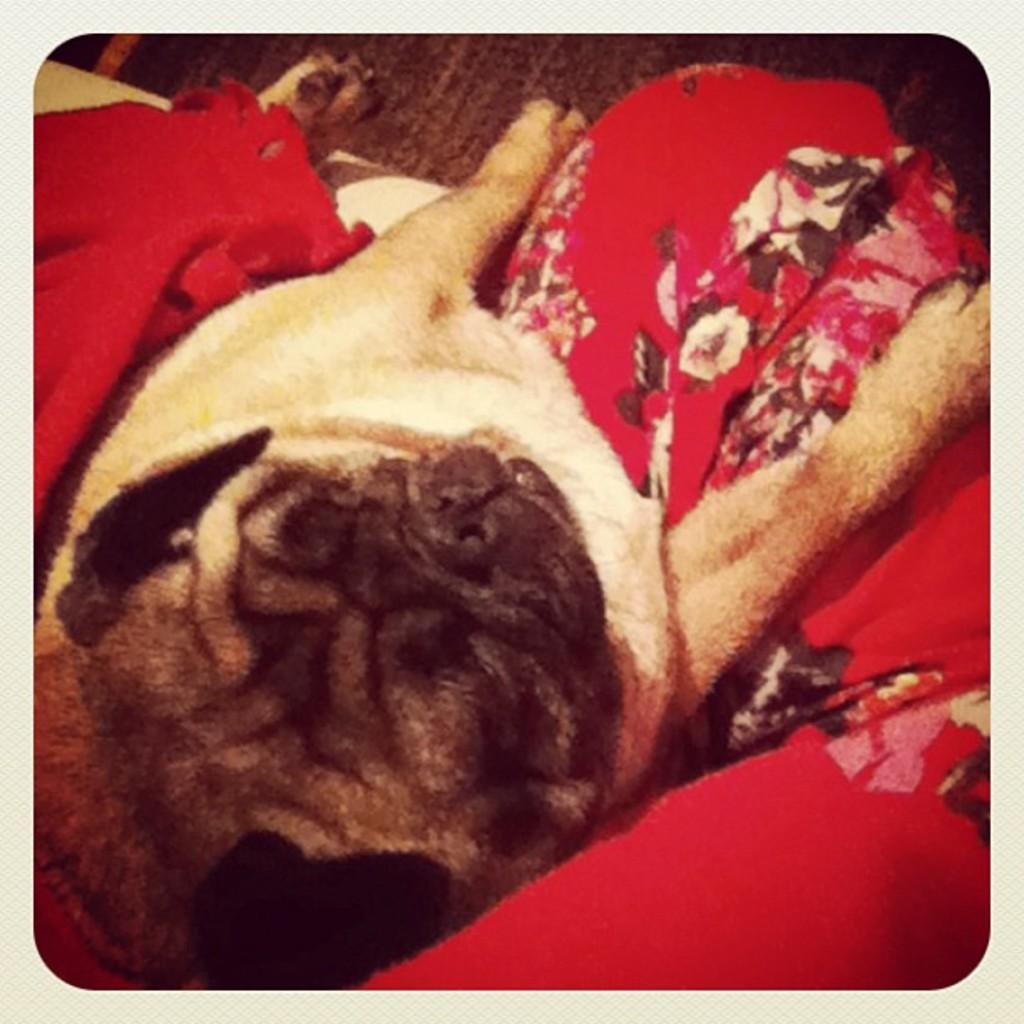Please provide a concise description of this image. In this picture I can observe a dog. The dog is in cream and black color. I can observe red color cloth on the dog. In the background there is a floor. 